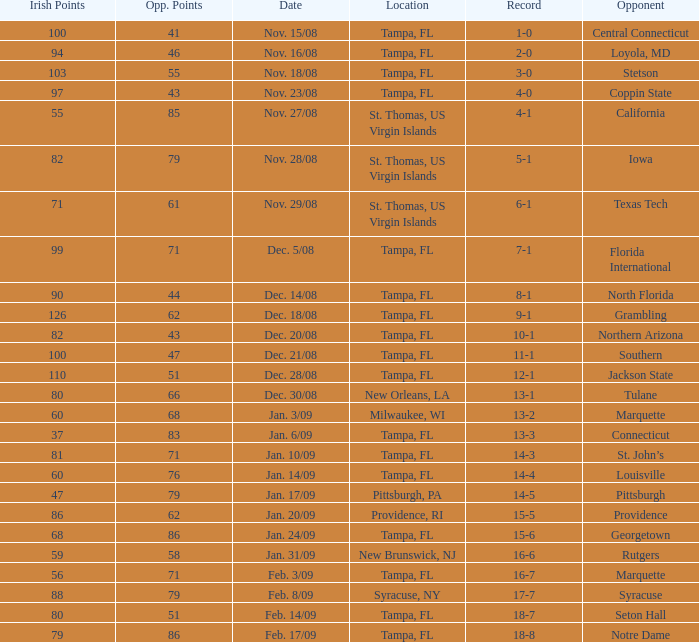What is the number of opponents where the location is syracuse, ny? 1.0. 